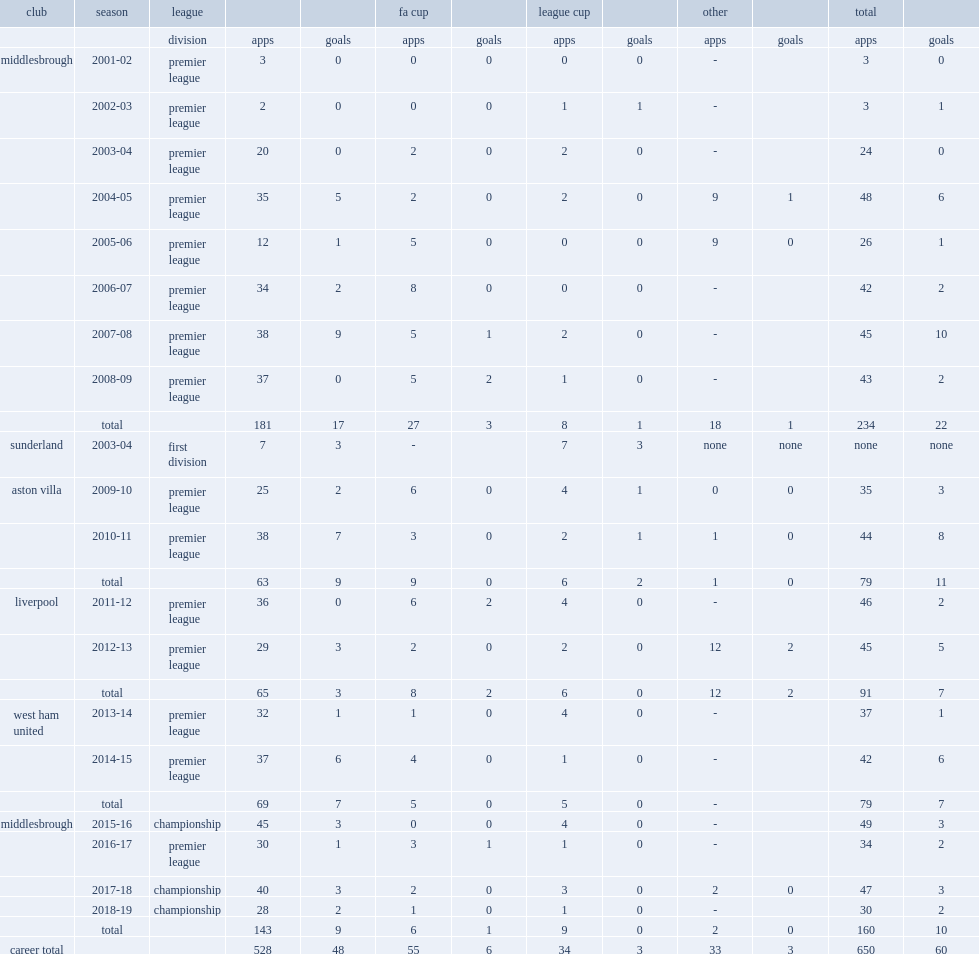In 2011, which league did stewart downing make his debut in liverpool's first match in 2011-12? Premier league. 